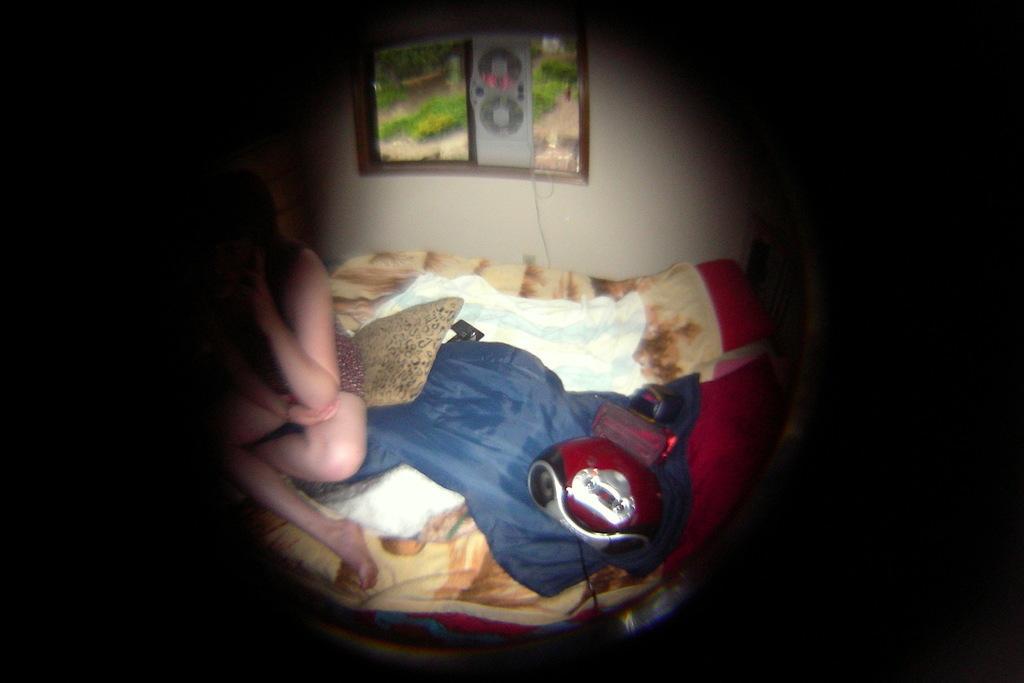Can you describe this image briefly? In this image in the center there are clothes and on the left side there is a person sitting. In the background there is a window and outside of the window there's grass on the ground. 